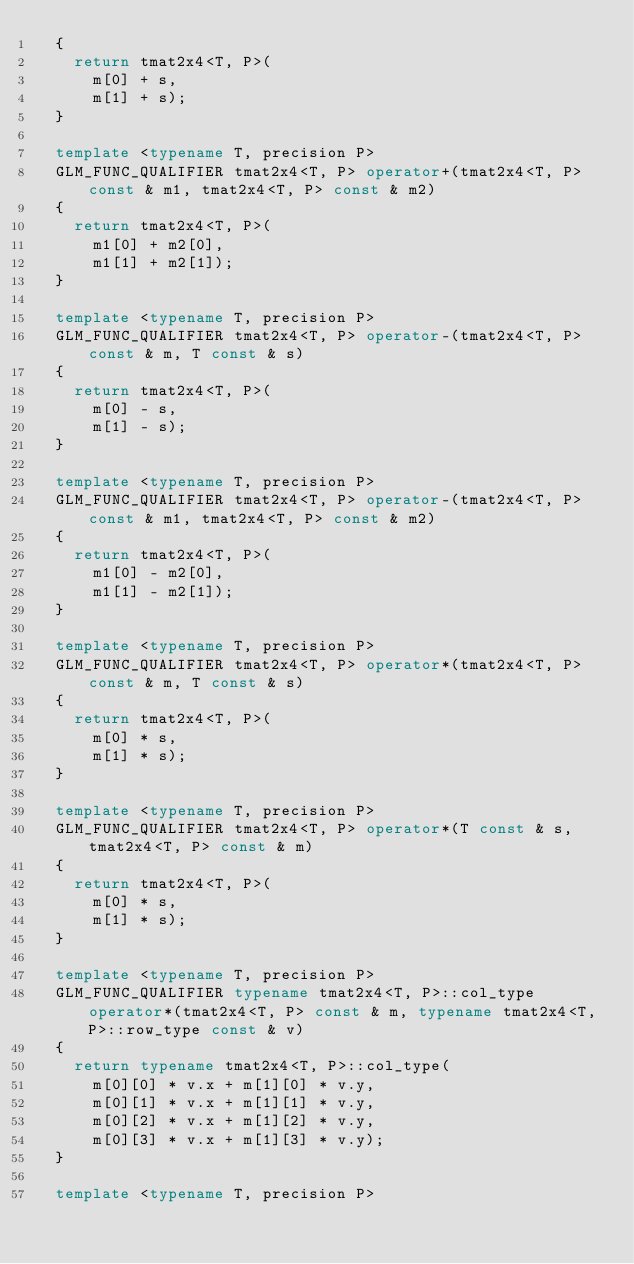<code> <loc_0><loc_0><loc_500><loc_500><_C++_>	{
		return tmat2x4<T, P>(
			m[0] + s,
			m[1] + s);
	}

	template <typename T, precision P> 
	GLM_FUNC_QUALIFIER tmat2x4<T, P> operator+(tmat2x4<T, P> const & m1, tmat2x4<T, P> const & m2)
	{
		return tmat2x4<T, P>(
			m1[0] + m2[0],
			m1[1] + m2[1]);
	}

	template <typename T, precision P> 
	GLM_FUNC_QUALIFIER tmat2x4<T, P> operator-(tmat2x4<T, P> const & m, T const & s)
	{
		return tmat2x4<T, P>(
			m[0] - s,
			m[1] - s);
	}

	template <typename T, precision P>
	GLM_FUNC_QUALIFIER tmat2x4<T, P> operator-(tmat2x4<T, P> const & m1, tmat2x4<T, P> const & m2)
	{
		return tmat2x4<T, P>(
			m1[0] - m2[0],
			m1[1] - m2[1]);
	}

	template <typename T, precision P>
	GLM_FUNC_QUALIFIER tmat2x4<T, P> operator*(tmat2x4<T, P> const & m, T const & s)
	{
		return tmat2x4<T, P>(
			m[0] * s,
			m[1] * s);
	}

	template <typename T, precision P> 
	GLM_FUNC_QUALIFIER tmat2x4<T, P> operator*(T const & s, tmat2x4<T, P> const & m)
	{
		return tmat2x4<T, P>(
			m[0] * s,
			m[1] * s);
	}

	template <typename T, precision P>
	GLM_FUNC_QUALIFIER typename tmat2x4<T, P>::col_type operator*(tmat2x4<T, P> const & m, typename tmat2x4<T, P>::row_type const & v)
	{
		return typename tmat2x4<T, P>::col_type(
			m[0][0] * v.x + m[1][0] * v.y,
			m[0][1] * v.x + m[1][1] * v.y,
			m[0][2] * v.x + m[1][2] * v.y,
			m[0][3] * v.x + m[1][3] * v.y);
	}

	template <typename T, precision P></code> 